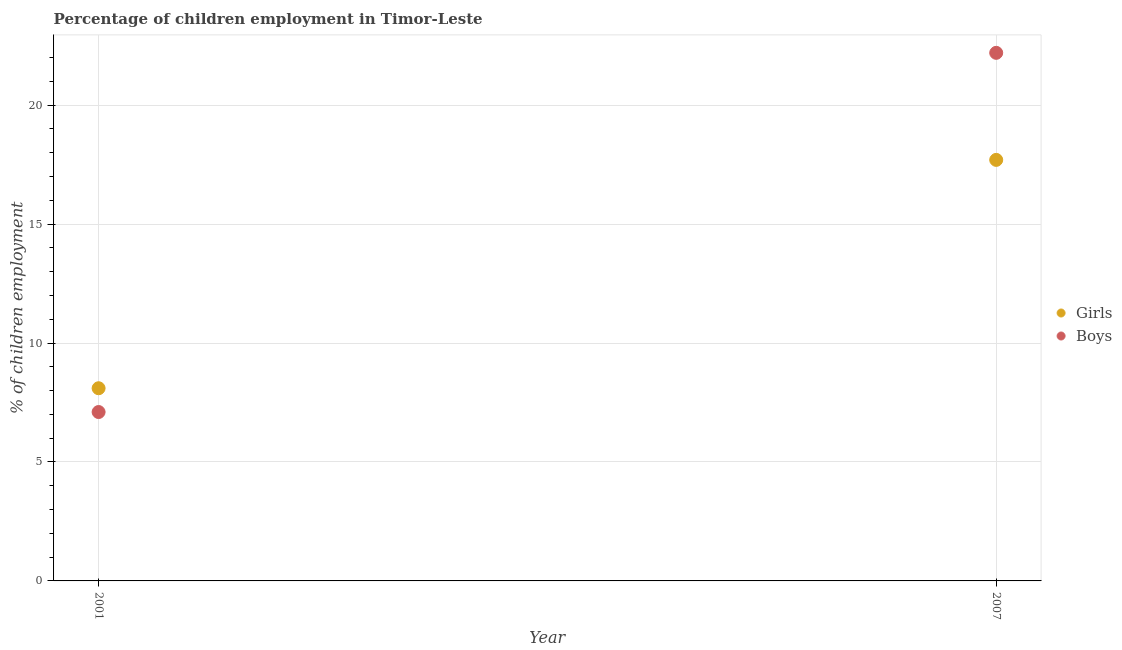Is the number of dotlines equal to the number of legend labels?
Provide a succinct answer. Yes. Across all years, what is the maximum percentage of employed girls?
Keep it short and to the point. 17.7. In which year was the percentage of employed girls maximum?
Keep it short and to the point. 2007. In which year was the percentage of employed boys minimum?
Provide a short and direct response. 2001. What is the total percentage of employed boys in the graph?
Offer a very short reply. 29.3. What is the difference between the percentage of employed boys in 2007 and the percentage of employed girls in 2001?
Keep it short and to the point. 14.1. What is the average percentage of employed girls per year?
Ensure brevity in your answer.  12.9. In the year 2007, what is the difference between the percentage of employed girls and percentage of employed boys?
Offer a terse response. -4.5. What is the ratio of the percentage of employed girls in 2001 to that in 2007?
Offer a very short reply. 0.46. Is the percentage of employed boys in 2001 less than that in 2007?
Your answer should be very brief. Yes. Is the percentage of employed boys strictly greater than the percentage of employed girls over the years?
Provide a succinct answer. No. Does the graph contain any zero values?
Offer a terse response. No. Where does the legend appear in the graph?
Your response must be concise. Center right. What is the title of the graph?
Your answer should be very brief. Percentage of children employment in Timor-Leste. What is the label or title of the Y-axis?
Your answer should be very brief. % of children employment. What is the % of children employment in Girls in 2001?
Offer a very short reply. 8.1. What is the % of children employment of Boys in 2001?
Keep it short and to the point. 7.1. What is the total % of children employment of Girls in the graph?
Your answer should be compact. 25.8. What is the total % of children employment of Boys in the graph?
Your answer should be compact. 29.3. What is the difference between the % of children employment of Boys in 2001 and that in 2007?
Keep it short and to the point. -15.1. What is the difference between the % of children employment of Girls in 2001 and the % of children employment of Boys in 2007?
Ensure brevity in your answer.  -14.1. What is the average % of children employment in Girls per year?
Provide a succinct answer. 12.9. What is the average % of children employment of Boys per year?
Your response must be concise. 14.65. In the year 2001, what is the difference between the % of children employment of Girls and % of children employment of Boys?
Provide a succinct answer. 1. What is the ratio of the % of children employment of Girls in 2001 to that in 2007?
Give a very brief answer. 0.46. What is the ratio of the % of children employment in Boys in 2001 to that in 2007?
Make the answer very short. 0.32. What is the difference between the highest and the lowest % of children employment in Girls?
Provide a succinct answer. 9.6. 